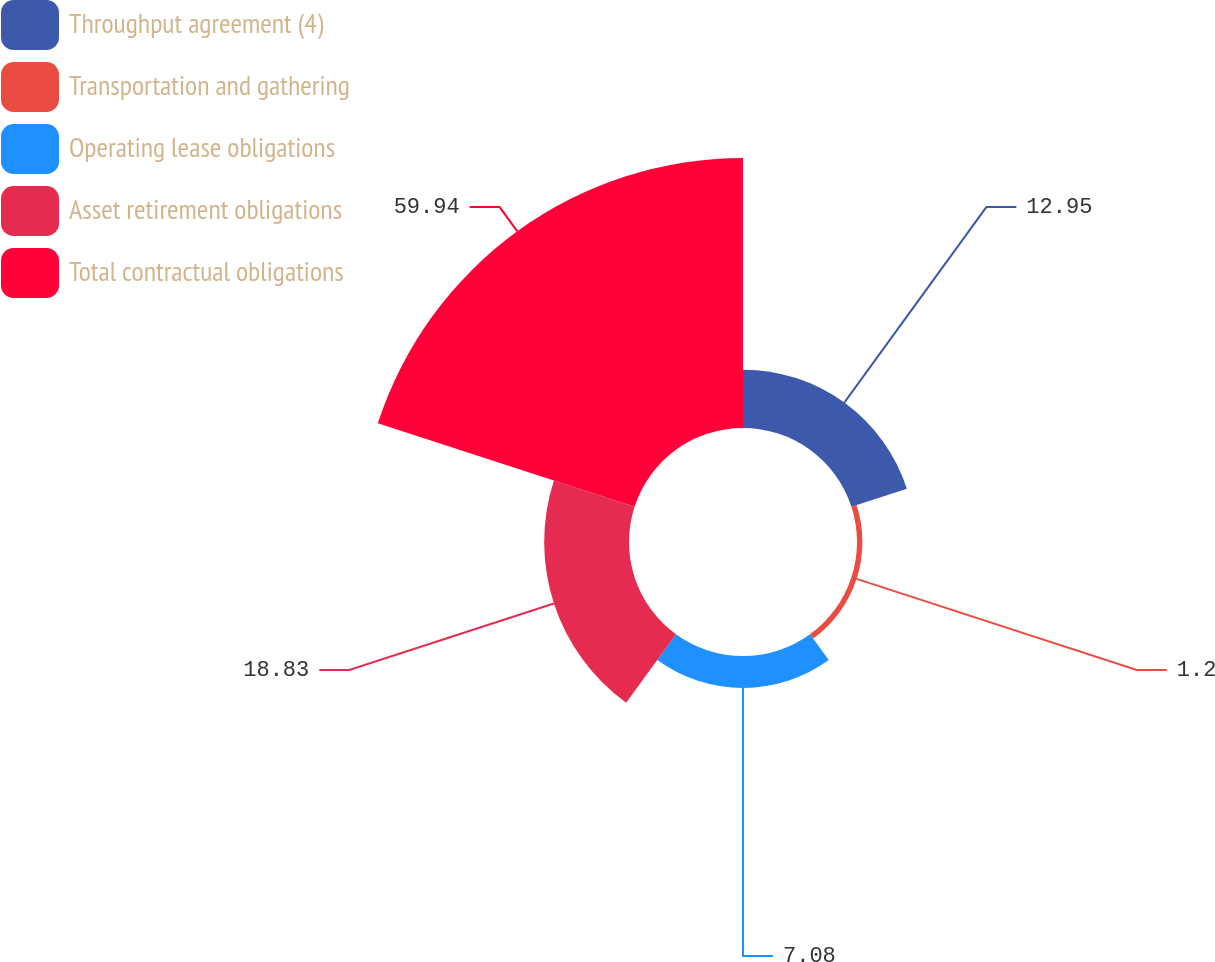<chart> <loc_0><loc_0><loc_500><loc_500><pie_chart><fcel>Throughput agreement (4)<fcel>Transportation and gathering<fcel>Operating lease obligations<fcel>Asset retirement obligations<fcel>Total contractual obligations<nl><fcel>12.95%<fcel>1.2%<fcel>7.08%<fcel>18.83%<fcel>59.94%<nl></chart> 